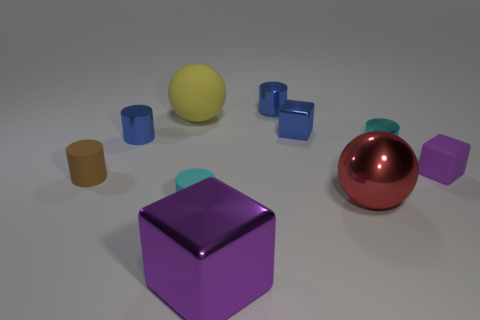Subtract all rubber cylinders. How many cylinders are left? 3 Subtract all brown cylinders. How many cylinders are left? 4 Subtract all balls. How many objects are left? 8 Subtract 1 blocks. How many blocks are left? 2 Subtract all blue blocks. How many cyan cylinders are left? 2 Subtract all big purple metal blocks. Subtract all red metal spheres. How many objects are left? 8 Add 4 tiny metallic blocks. How many tiny metallic blocks are left? 5 Add 5 tiny cyan spheres. How many tiny cyan spheres exist? 5 Subtract 0 gray blocks. How many objects are left? 10 Subtract all purple spheres. Subtract all gray cylinders. How many spheres are left? 2 